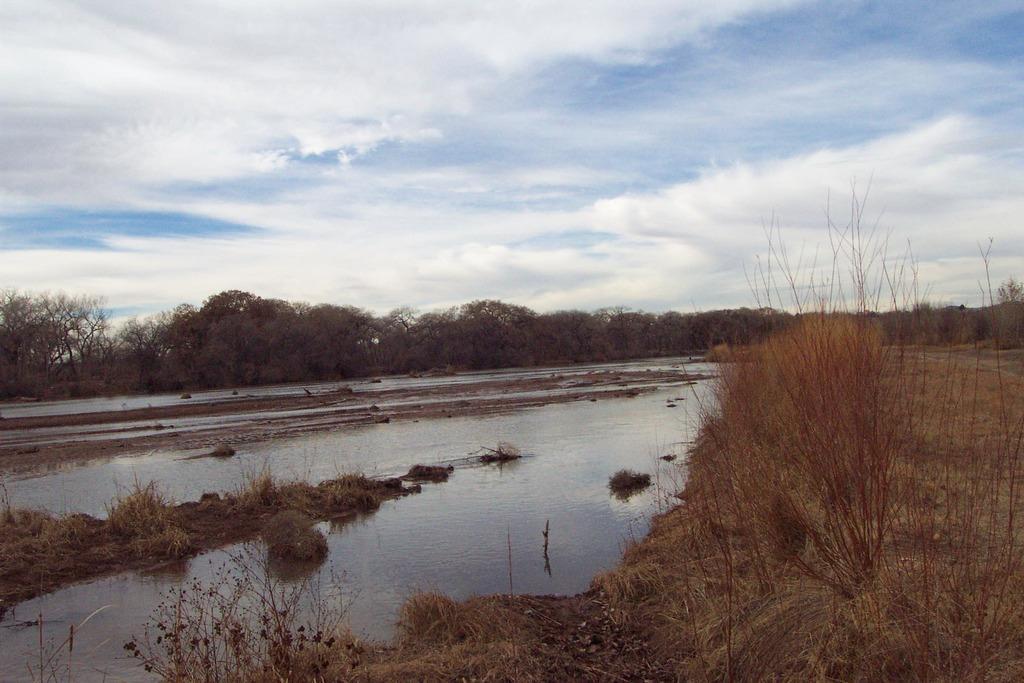In one or two sentences, can you explain what this image depicts? In this image I can see a lake with some dry grass. In the center of the image I can see some trees in the right bottom corner I can see some dried plants and ground at the top of the image I can see the sky. 